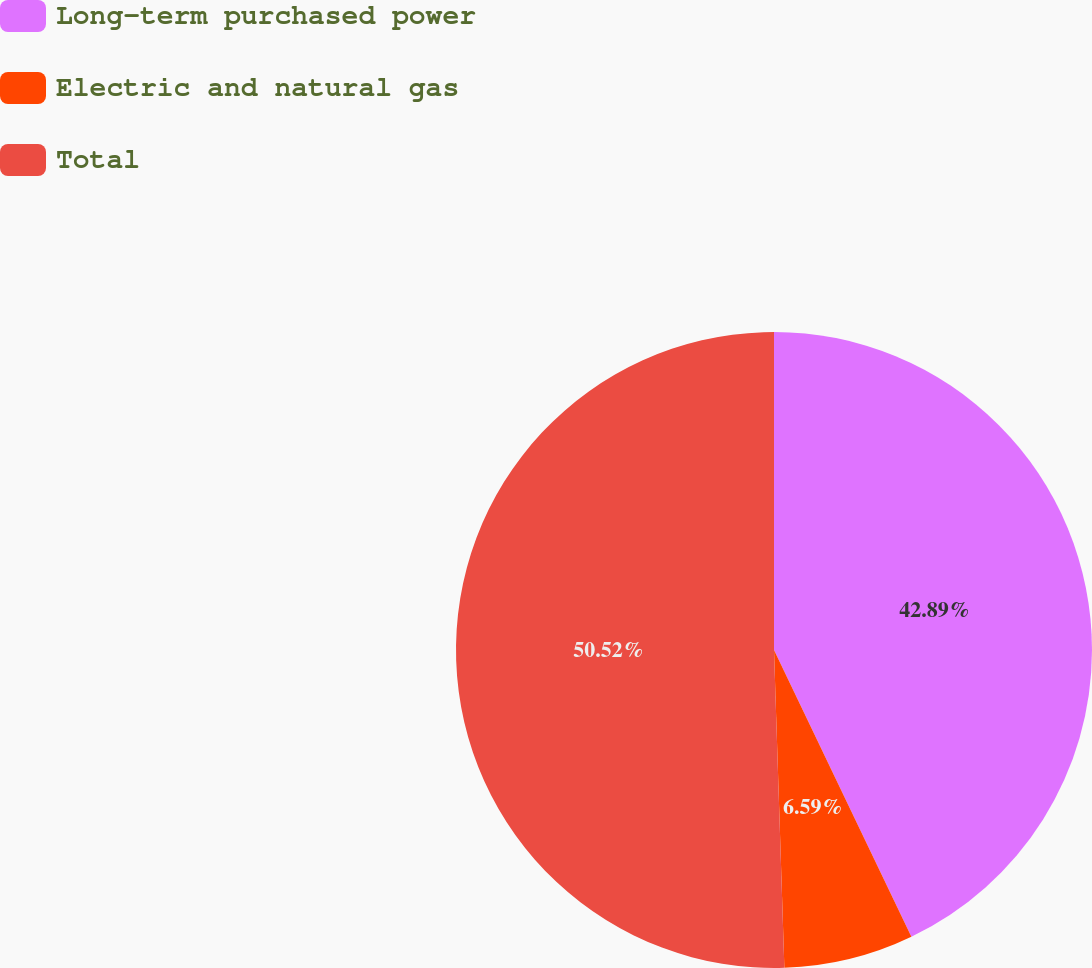Convert chart. <chart><loc_0><loc_0><loc_500><loc_500><pie_chart><fcel>Long-term purchased power<fcel>Electric and natural gas<fcel>Total<nl><fcel>42.89%<fcel>6.59%<fcel>50.52%<nl></chart> 